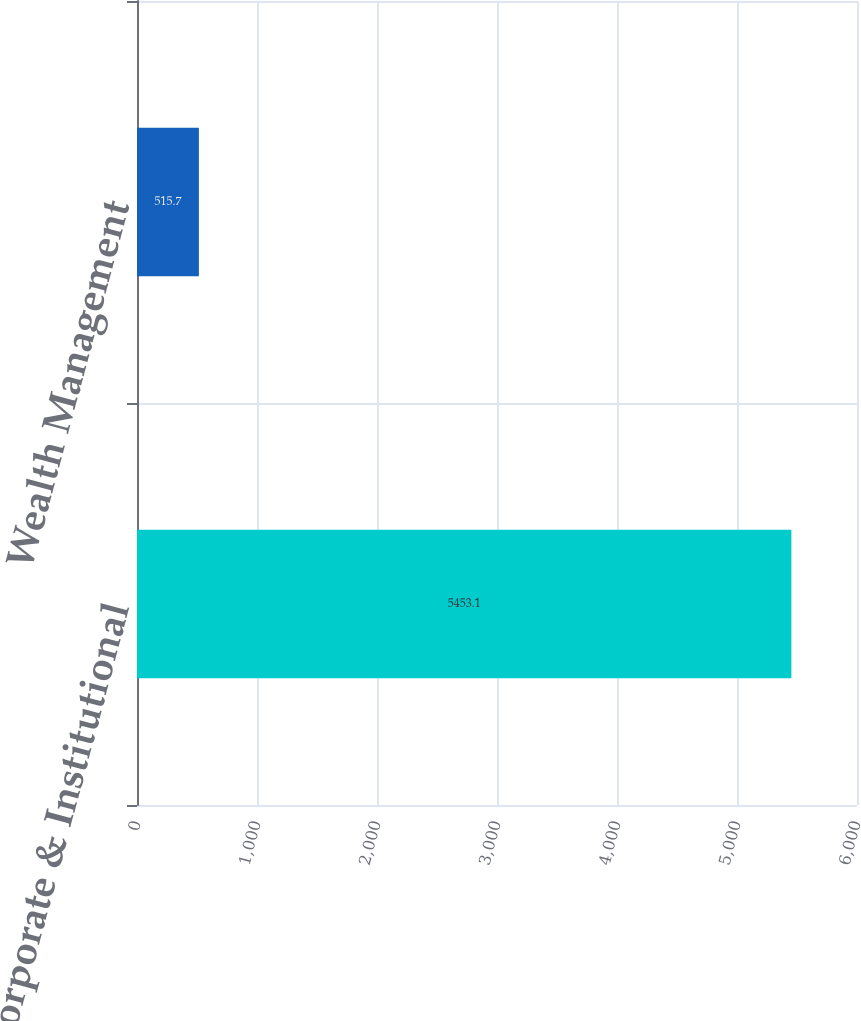<chart> <loc_0><loc_0><loc_500><loc_500><bar_chart><fcel>Corporate & Institutional<fcel>Wealth Management<nl><fcel>5453.1<fcel>515.7<nl></chart> 